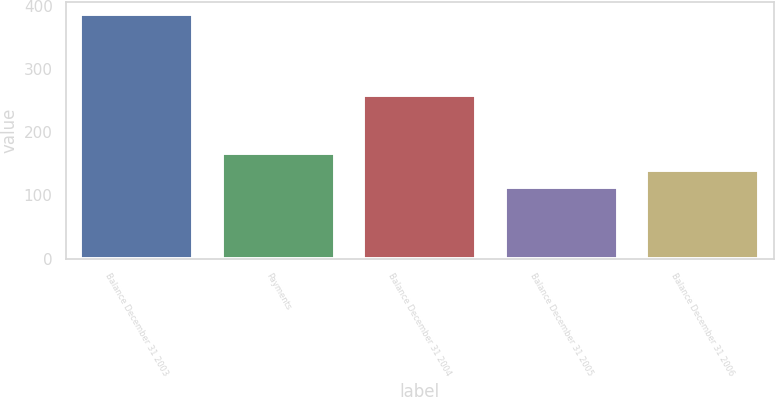Convert chart to OTSL. <chart><loc_0><loc_0><loc_500><loc_500><bar_chart><fcel>Balance December 31 2003<fcel>Payments<fcel>Balance December 31 2004<fcel>Balance December 31 2005<fcel>Balance December 31 2006<nl><fcel>387<fcel>167.8<fcel>259<fcel>113<fcel>140.4<nl></chart> 